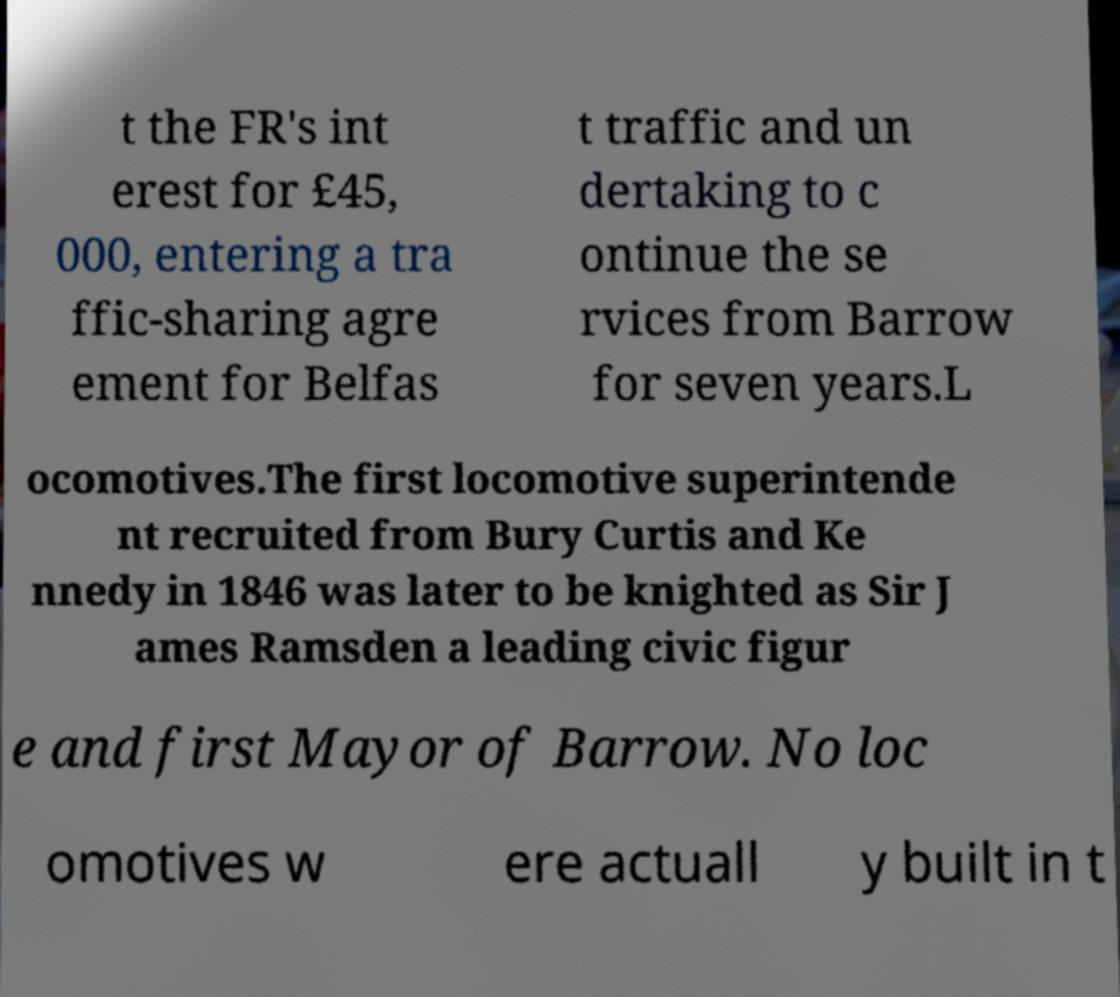Could you extract and type out the text from this image? t the FR's int erest for £45, 000, entering a tra ffic-sharing agre ement for Belfas t traffic and un dertaking to c ontinue the se rvices from Barrow for seven years.L ocomotives.The first locomotive superintende nt recruited from Bury Curtis and Ke nnedy in 1846 was later to be knighted as Sir J ames Ramsden a leading civic figur e and first Mayor of Barrow. No loc omotives w ere actuall y built in t 